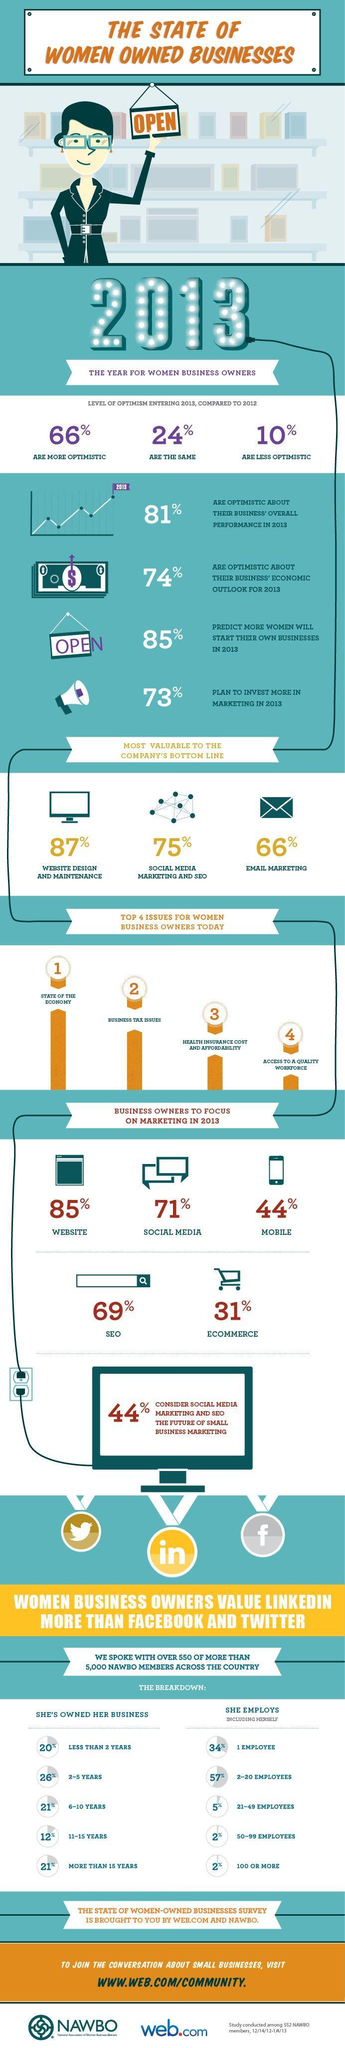Where does business tax issues rank for a woman business owner, first, second, or third?
Answer the question with a short phrase. second What percentage of women owned businesses had 50-100+ employees? 2% What percentage of businesses were owned from 6-10 years or 15+ years? 21% What percentage of business owners are concentrating on mobile marketing, 85%, 71%, or 44%? 44% Which is the third most valuable to the company's bottom-line? Email Marketing What percentage of womenprenuers are not over optimistic or under optimistic about business in 2013? 24% 